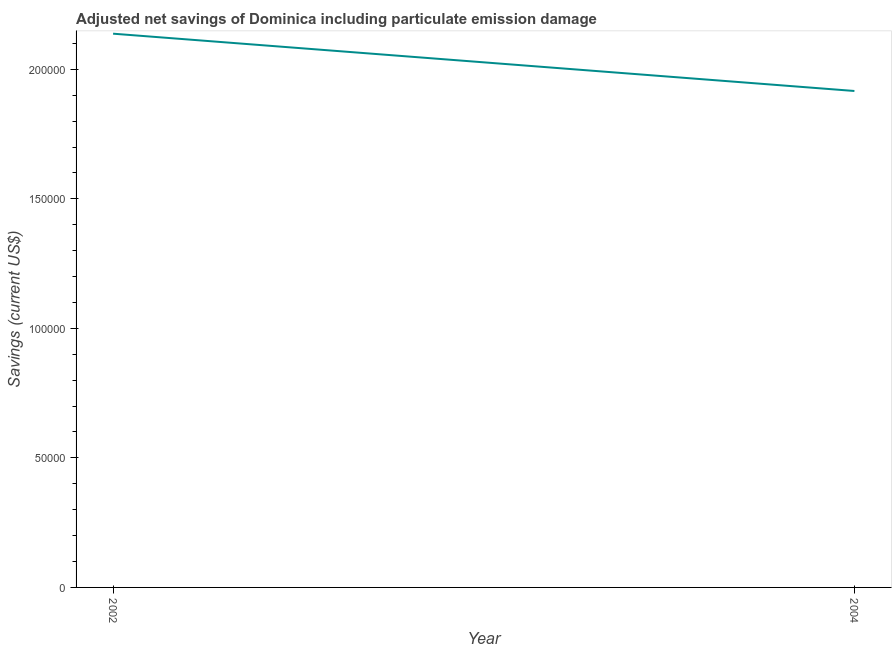What is the adjusted net savings in 2002?
Keep it short and to the point. 2.14e+05. Across all years, what is the maximum adjusted net savings?
Ensure brevity in your answer.  2.14e+05. Across all years, what is the minimum adjusted net savings?
Your answer should be compact. 1.92e+05. In which year was the adjusted net savings maximum?
Your response must be concise. 2002. In which year was the adjusted net savings minimum?
Make the answer very short. 2004. What is the sum of the adjusted net savings?
Offer a very short reply. 4.05e+05. What is the difference between the adjusted net savings in 2002 and 2004?
Keep it short and to the point. 2.21e+04. What is the average adjusted net savings per year?
Your answer should be compact. 2.03e+05. What is the median adjusted net savings?
Keep it short and to the point. 2.03e+05. Do a majority of the years between 2004 and 2002 (inclusive) have adjusted net savings greater than 180000 US$?
Your answer should be very brief. No. What is the ratio of the adjusted net savings in 2002 to that in 2004?
Provide a succinct answer. 1.12. Does the adjusted net savings monotonically increase over the years?
Keep it short and to the point. No. How many lines are there?
Provide a short and direct response. 1. How many years are there in the graph?
Provide a short and direct response. 2. What is the title of the graph?
Make the answer very short. Adjusted net savings of Dominica including particulate emission damage. What is the label or title of the Y-axis?
Ensure brevity in your answer.  Savings (current US$). What is the Savings (current US$) of 2002?
Provide a succinct answer. 2.14e+05. What is the Savings (current US$) in 2004?
Keep it short and to the point. 1.92e+05. What is the difference between the Savings (current US$) in 2002 and 2004?
Keep it short and to the point. 2.21e+04. What is the ratio of the Savings (current US$) in 2002 to that in 2004?
Keep it short and to the point. 1.11. 